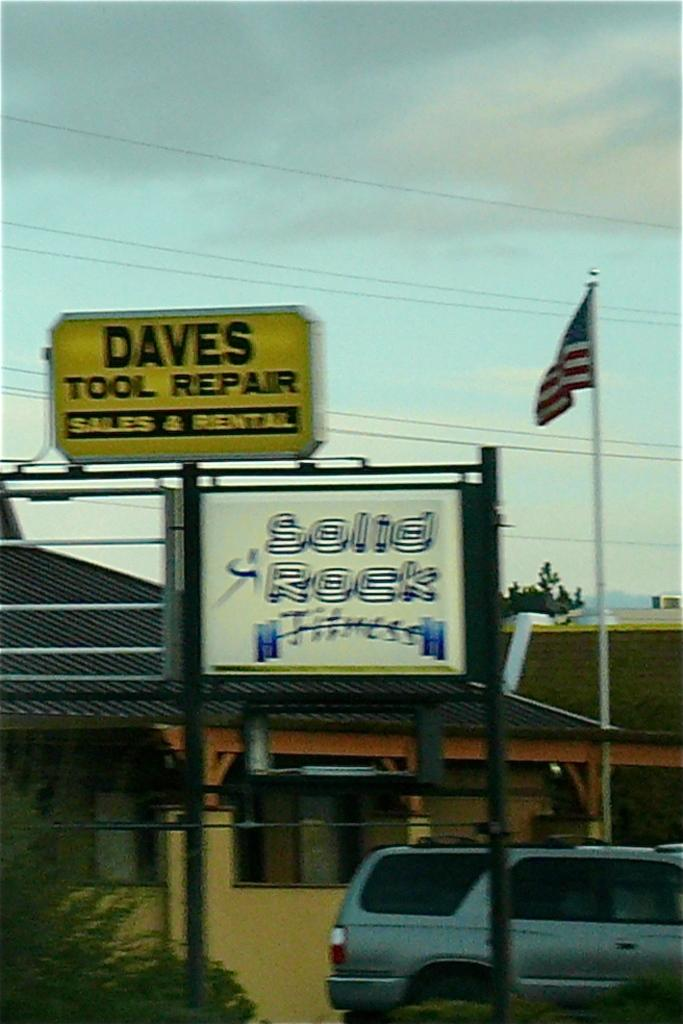What type of structures can be seen in the image? There are houses in the image. What else can be seen in the image besides houses? There are hoardings, plants, a car, a tree, and clouds visible in the image. Where is the flag located in the image? The flag is on the right side of the image. Can you see a wren perched on the tree in the image? There is no wren visible in the image; only a tree and clouds can be seen in the background. What type of work is being done by the monkey in the image? There is no monkey present in the image, so it is not possible to determine what work it might be doing. 